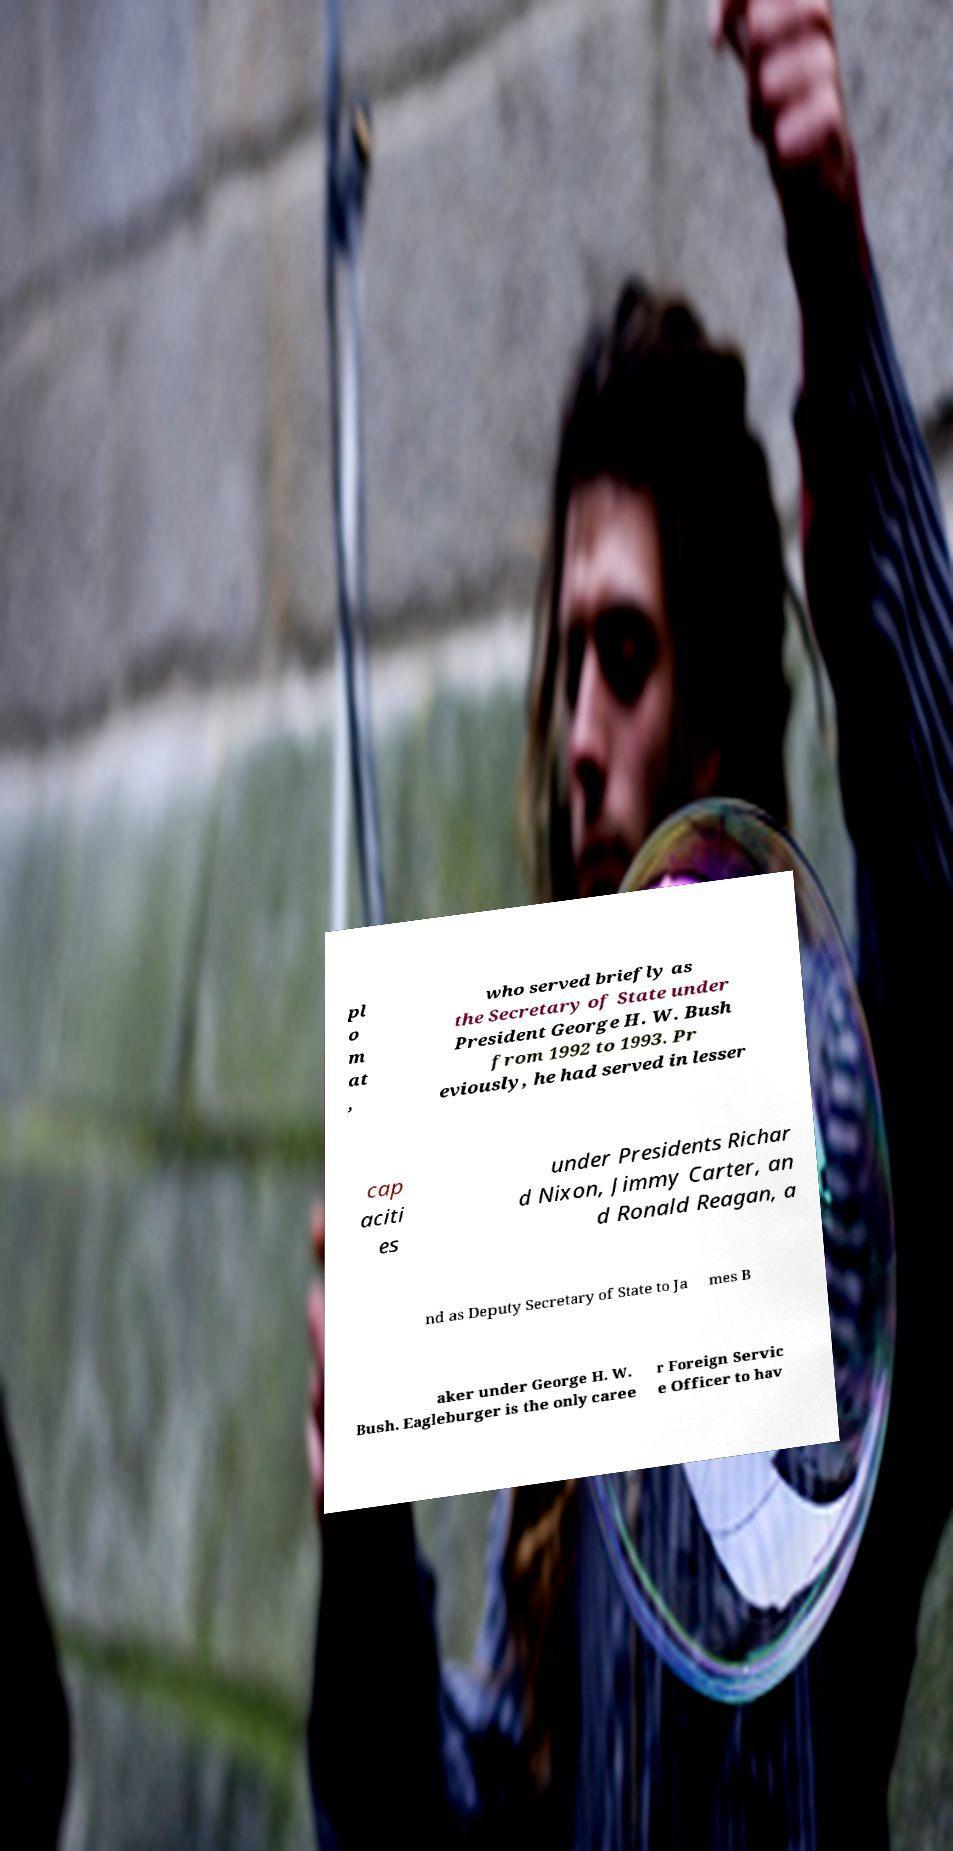There's text embedded in this image that I need extracted. Can you transcribe it verbatim? pl o m at , who served briefly as the Secretary of State under President George H. W. Bush from 1992 to 1993. Pr eviously, he had served in lesser cap aciti es under Presidents Richar d Nixon, Jimmy Carter, an d Ronald Reagan, a nd as Deputy Secretary of State to Ja mes B aker under George H. W. Bush. Eagleburger is the only caree r Foreign Servic e Officer to hav 